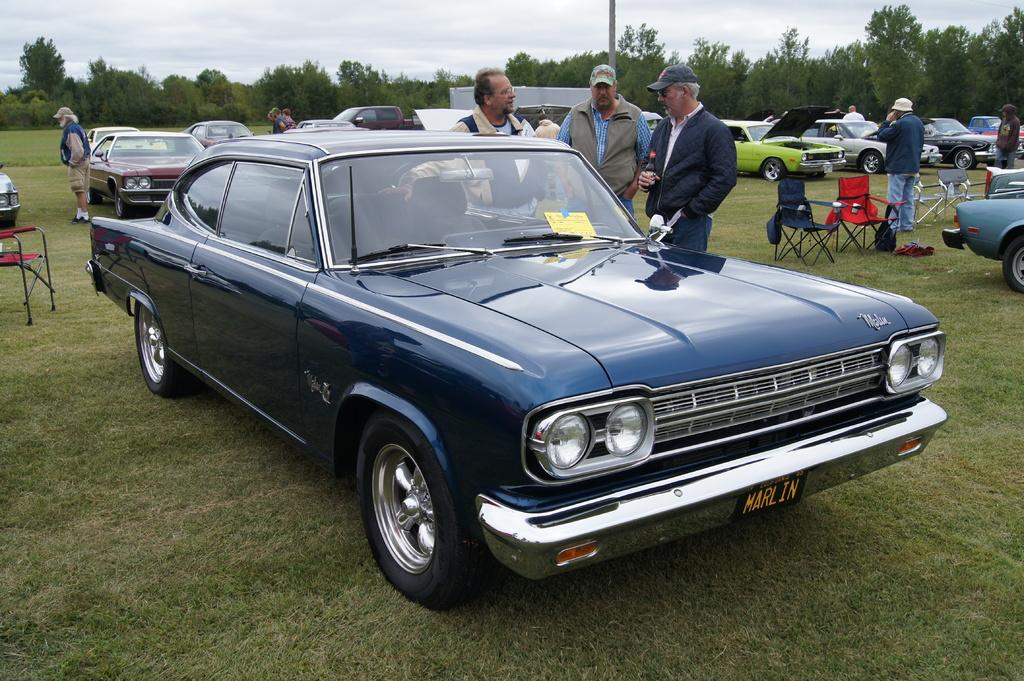<image>
Describe the image concisely. three elderly men standing next to a classic blue malibu. 